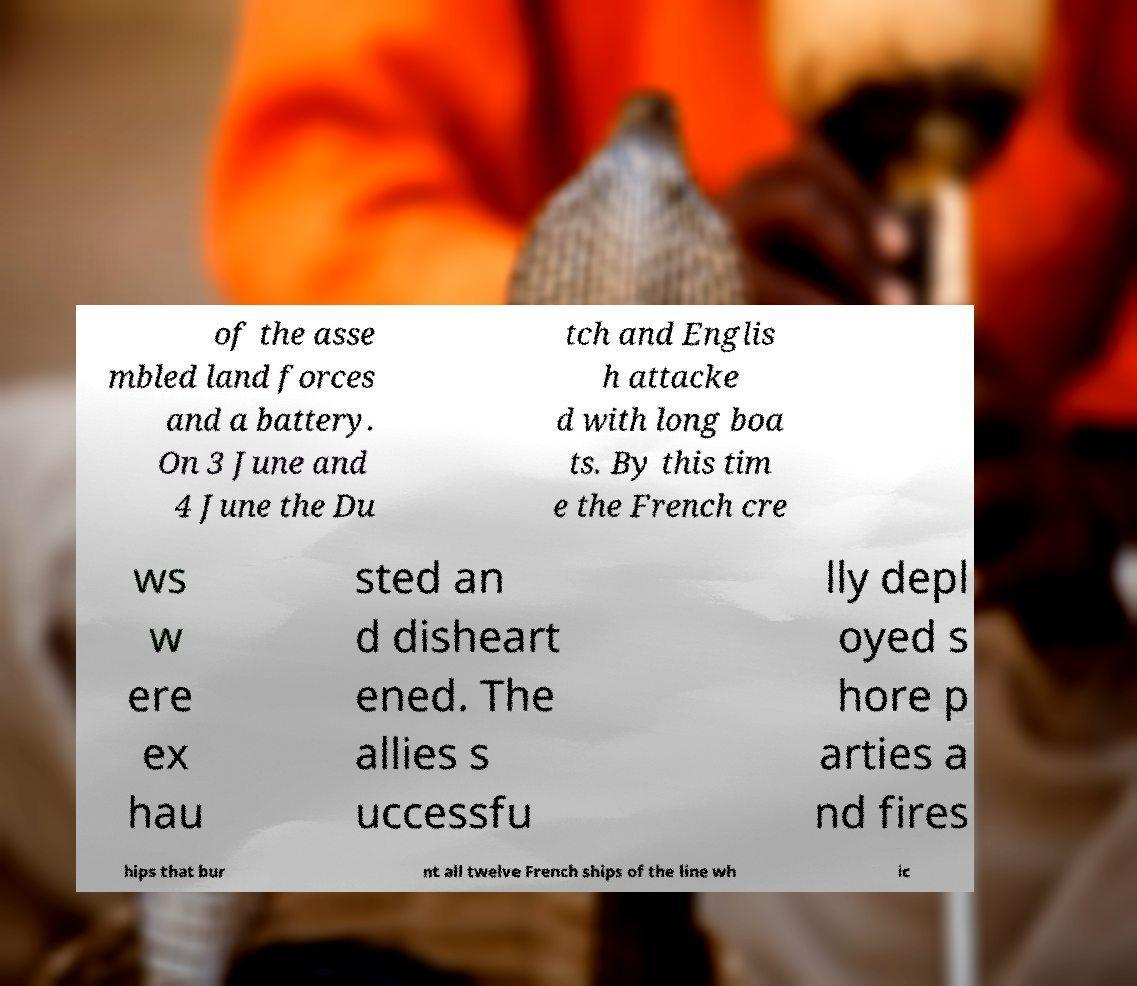Could you assist in decoding the text presented in this image and type it out clearly? of the asse mbled land forces and a battery. On 3 June and 4 June the Du tch and Englis h attacke d with long boa ts. By this tim e the French cre ws w ere ex hau sted an d disheart ened. The allies s uccessfu lly depl oyed s hore p arties a nd fires hips that bur nt all twelve French ships of the line wh ic 